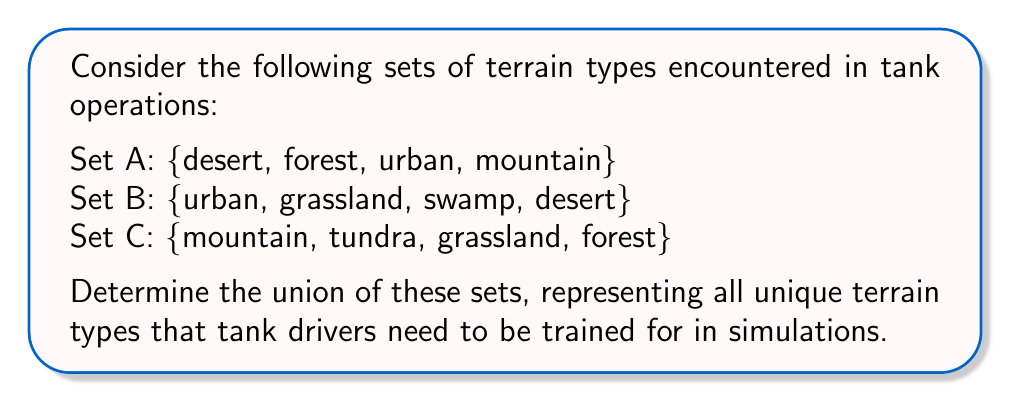Provide a solution to this math problem. To solve this problem, we need to understand the concept of union in set theory and apply it to our given sets.

1. The union of sets is defined as all unique elements that appear in any of the sets. We denote the union operation with the symbol $\cup$.

2. Let's start by combining sets A and B:
   $A \cup B = \{desert, forest, urban, mountain, grassland, swamp\}$

3. Now, let's add set C to our result:
   $(A \cup B) \cup C$

4. We need to include any elements from C that are not already in our combined set:
   - mountain and forest are already included
   - tundra and grassland need to be added

5. Our final union of all three sets is:
   $A \cup B \cup C = \{desert, forest, urban, mountain, grassland, swamp, tundra\}$

6. To verify, let's count the unique elements:
   $|A \cup B \cup C| = 7$

This result represents all the unique terrain types that tank drivers need to be trained for in simulations, covering a wide range of operational environments.
Answer: $A \cup B \cup C = \{desert, forest, urban, mountain, grassland, swamp, tundra\}$ 